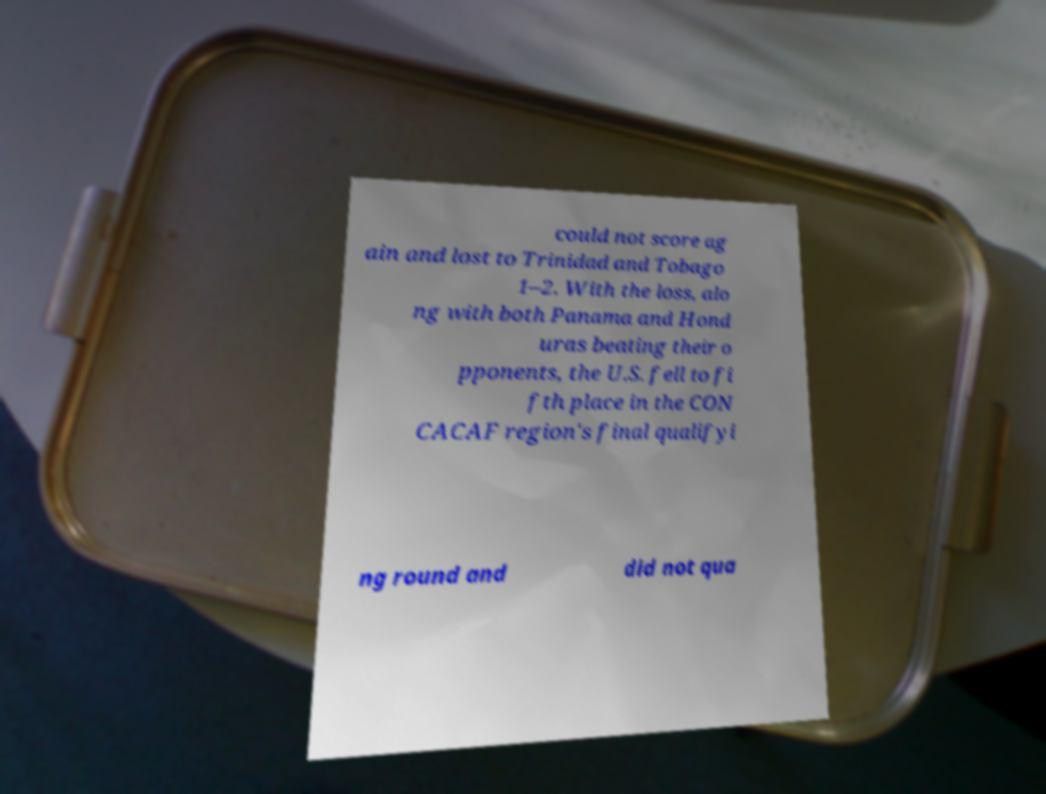There's text embedded in this image that I need extracted. Can you transcribe it verbatim? could not score ag ain and lost to Trinidad and Tobago 1–2. With the loss, alo ng with both Panama and Hond uras beating their o pponents, the U.S. fell to fi fth place in the CON CACAF region's final qualifyi ng round and did not qua 